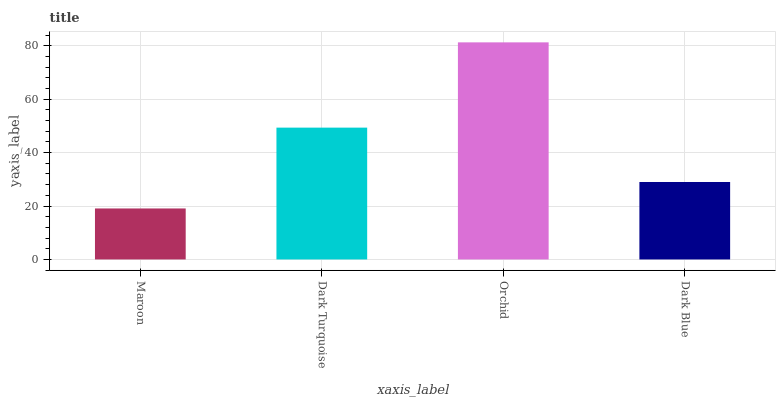Is Maroon the minimum?
Answer yes or no. Yes. Is Orchid the maximum?
Answer yes or no. Yes. Is Dark Turquoise the minimum?
Answer yes or no. No. Is Dark Turquoise the maximum?
Answer yes or no. No. Is Dark Turquoise greater than Maroon?
Answer yes or no. Yes. Is Maroon less than Dark Turquoise?
Answer yes or no. Yes. Is Maroon greater than Dark Turquoise?
Answer yes or no. No. Is Dark Turquoise less than Maroon?
Answer yes or no. No. Is Dark Turquoise the high median?
Answer yes or no. Yes. Is Dark Blue the low median?
Answer yes or no. Yes. Is Maroon the high median?
Answer yes or no. No. Is Maroon the low median?
Answer yes or no. No. 